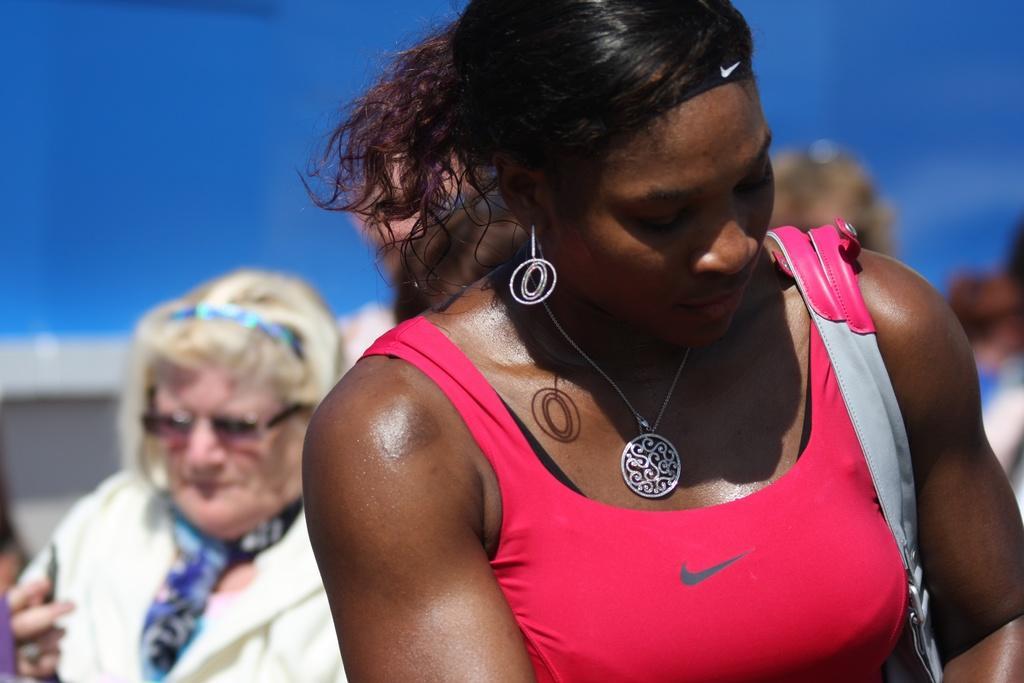Can you describe this image briefly? In this picture we can see a woman carrying a bag and at the back of her we can see some people and in the background we can see the sky. 